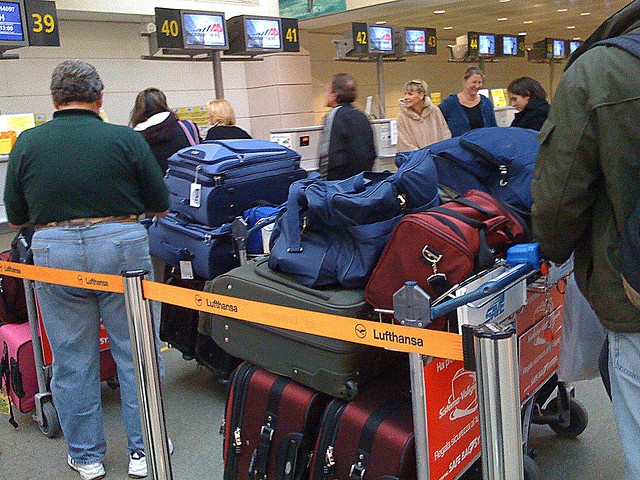Describe the objects in this image and their specific colors. I can see people in olive, black, gray, and teal tones, people in olive, black, gray, maroon, and darkgreen tones, handbag in olive, black, navy, and blue tones, suitcase in olive, black, gray, darkgreen, and purple tones, and suitcase in olive, black, navy, gray, and blue tones in this image. 